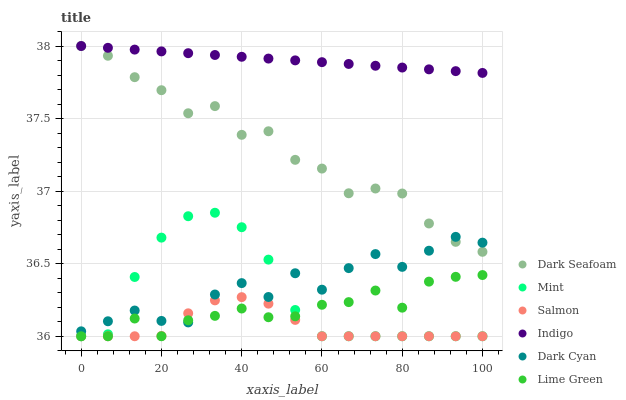Does Salmon have the minimum area under the curve?
Answer yes or no. Yes. Does Indigo have the maximum area under the curve?
Answer yes or no. Yes. Does Lime Green have the minimum area under the curve?
Answer yes or no. No. Does Lime Green have the maximum area under the curve?
Answer yes or no. No. Is Indigo the smoothest?
Answer yes or no. Yes. Is Dark Cyan the roughest?
Answer yes or no. Yes. Is Lime Green the smoothest?
Answer yes or no. No. Is Lime Green the roughest?
Answer yes or no. No. Does Lime Green have the lowest value?
Answer yes or no. Yes. Does Dark Seafoam have the lowest value?
Answer yes or no. No. Does Dark Seafoam have the highest value?
Answer yes or no. Yes. Does Lime Green have the highest value?
Answer yes or no. No. Is Lime Green less than Dark Seafoam?
Answer yes or no. Yes. Is Dark Seafoam greater than Salmon?
Answer yes or no. Yes. Does Mint intersect Salmon?
Answer yes or no. Yes. Is Mint less than Salmon?
Answer yes or no. No. Is Mint greater than Salmon?
Answer yes or no. No. Does Lime Green intersect Dark Seafoam?
Answer yes or no. No. 